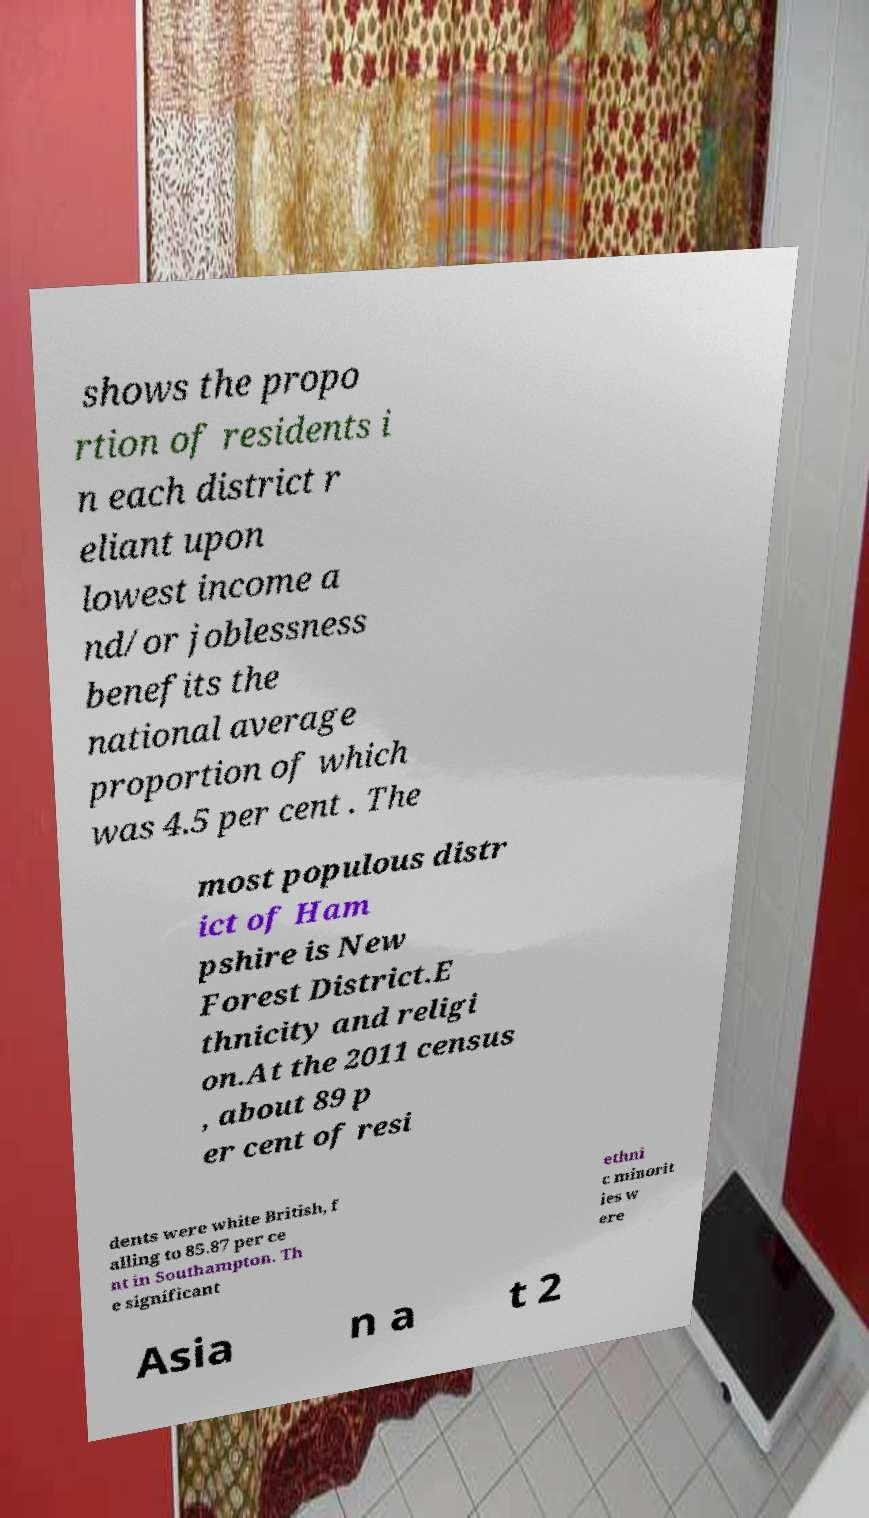There's text embedded in this image that I need extracted. Can you transcribe it verbatim? shows the propo rtion of residents i n each district r eliant upon lowest income a nd/or joblessness benefits the national average proportion of which was 4.5 per cent . The most populous distr ict of Ham pshire is New Forest District.E thnicity and religi on.At the 2011 census , about 89 p er cent of resi dents were white British, f alling to 85.87 per ce nt in Southampton. Th e significant ethni c minorit ies w ere Asia n a t 2 